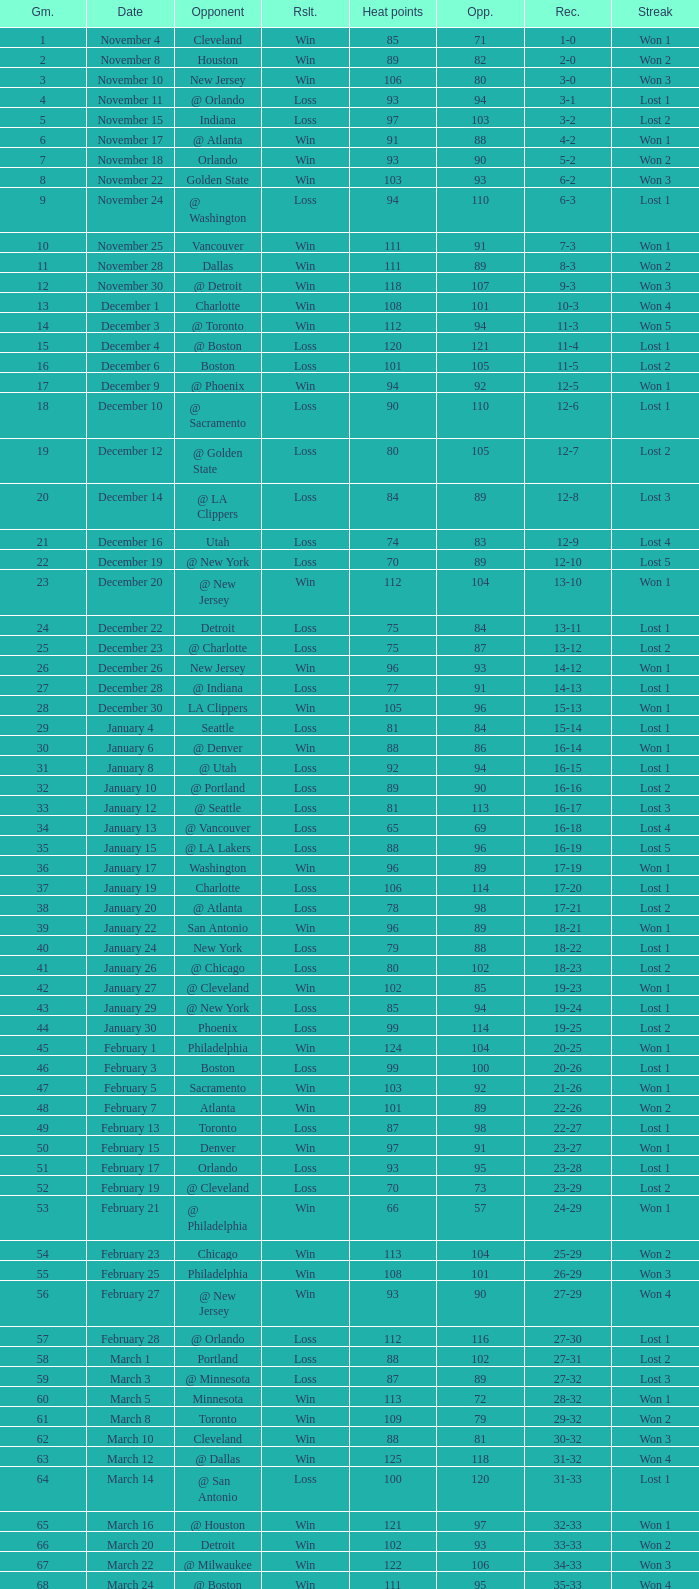What is the highest Game, when Opponents is less than 80, and when Record is "1-0"? 1.0. 